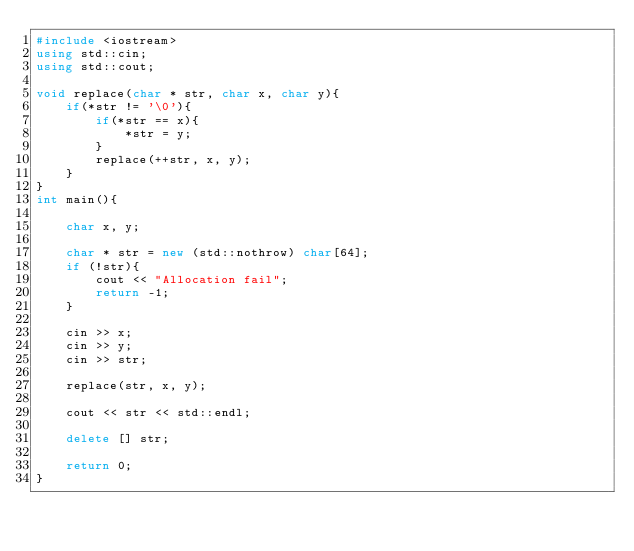Convert code to text. <code><loc_0><loc_0><loc_500><loc_500><_C++_>#include <iostream>
using std::cin;
using std::cout;

void replace(char * str, char x, char y){
    if(*str != '\0'){
        if(*str == x){
            *str = y;
        }
        replace(++str, x, y);
    }
}
int main(){

    char x, y;

    char * str = new (std::nothrow) char[64];
    if (!str){
        cout << "Allocation fail";
        return -1;
    }

    cin >> x;
    cin >> y;
    cin >> str;

    replace(str, x, y);

    cout << str << std::endl;

    delete [] str;

    return 0;
}
</code> 